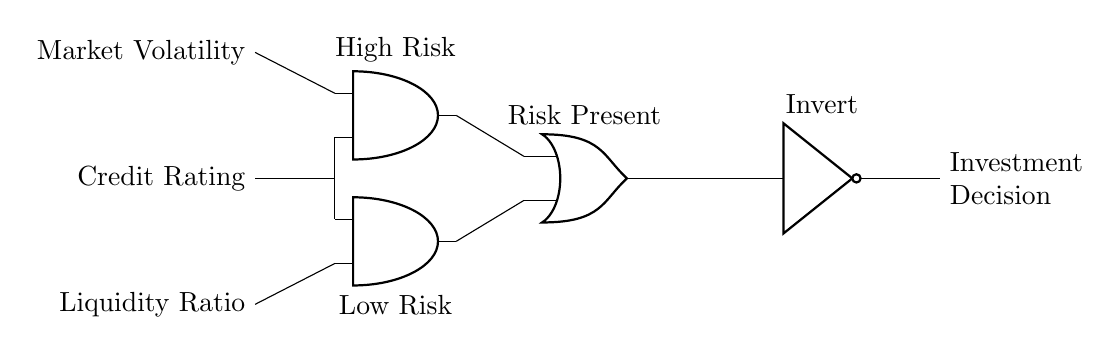What are the three input signals in the circuit? The circuit has three input signals labeled as Market Volatility, Credit Rating, and Liquidity Ratio. Each input represents a different factor that is assessed for financial risk.
Answer: Market Volatility, Credit Rating, Liquidity Ratio How many AND gates are present in the circuit? The circuit contains two AND gates, indicated by the symbols present in the diagram. Each AND gate processes a combination of inputs to determine a specific risk level.
Answer: Two What is the output of the OR gate? The OR gate combines outputs from the two AND gates to produce a single output signal that indicates the overall risk condition. This output can be interpreted as whether any risk is present based on the AND gate results.
Answer: Risk Present What does the NOT gate do in this circuit? The NOT gate inverts the output from the OR gate, meaning if the OR gate indicates risk is present, the NOT gate will output a decision to not invest, and vice versa. This transformation alters the investment decision based on the risk evaluation.
Answer: Invert What condition must be true for the output of the first AND gate to be high? For the output of the first AND gate to be high, both inputs must be high, which in this case means that both Market Volatility and Credit Rating must indicate high risk. This demonstrates the need for multiple risk factors to align for a high-risk evaluation.
Answer: High Risk What is the role of the second AND gate in decision-making? The second AND gate processes input signals to establish low-risk conditions based on the Liquidity Ratio and Credit Rating. It leads to a conclusion that supports investment, provided the signals indicate low-risk criteria based on the circuit logic.
Answer: Low Risk 